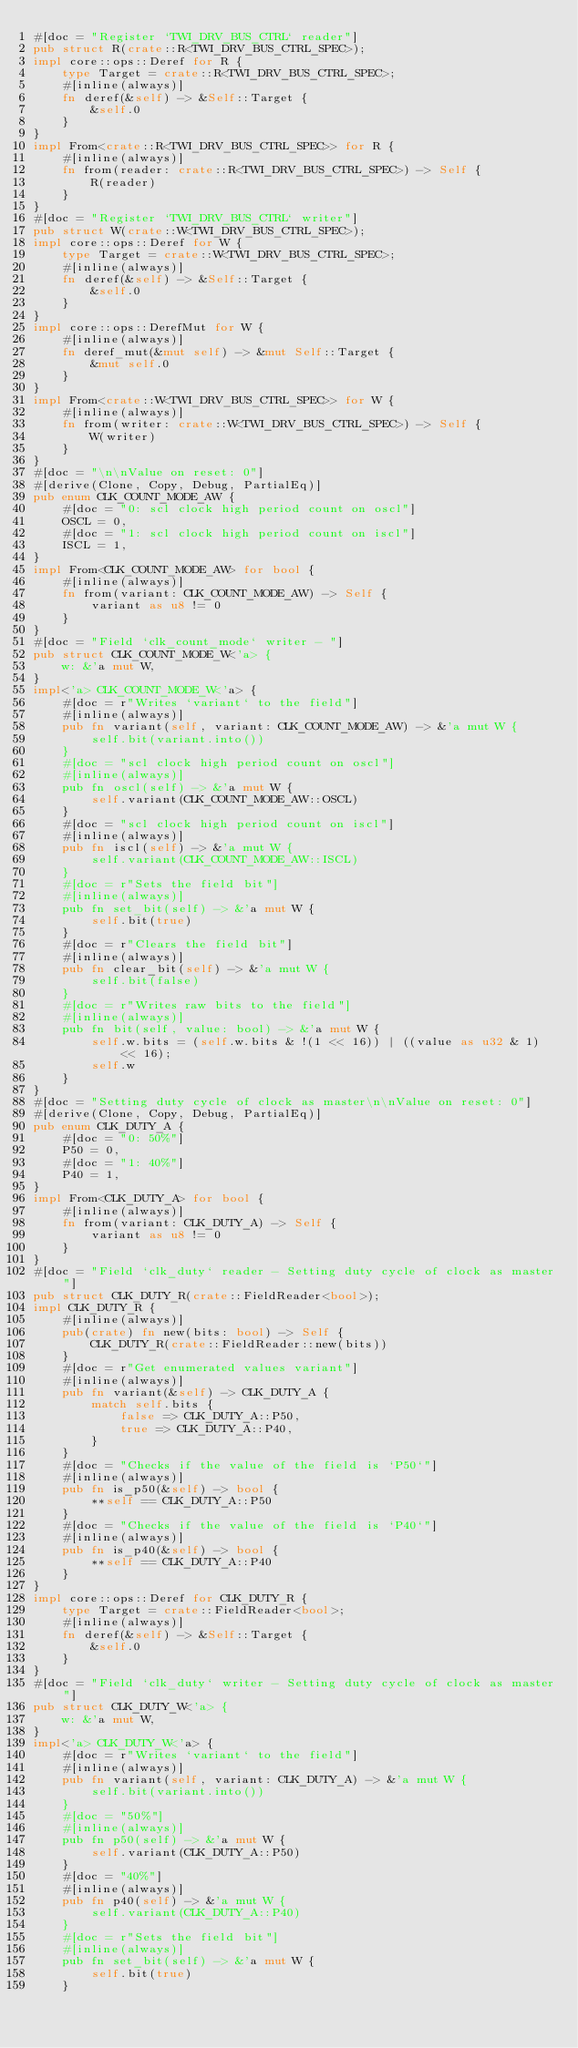Convert code to text. <code><loc_0><loc_0><loc_500><loc_500><_Rust_>#[doc = "Register `TWI_DRV_BUS_CTRL` reader"]
pub struct R(crate::R<TWI_DRV_BUS_CTRL_SPEC>);
impl core::ops::Deref for R {
    type Target = crate::R<TWI_DRV_BUS_CTRL_SPEC>;
    #[inline(always)]
    fn deref(&self) -> &Self::Target {
        &self.0
    }
}
impl From<crate::R<TWI_DRV_BUS_CTRL_SPEC>> for R {
    #[inline(always)]
    fn from(reader: crate::R<TWI_DRV_BUS_CTRL_SPEC>) -> Self {
        R(reader)
    }
}
#[doc = "Register `TWI_DRV_BUS_CTRL` writer"]
pub struct W(crate::W<TWI_DRV_BUS_CTRL_SPEC>);
impl core::ops::Deref for W {
    type Target = crate::W<TWI_DRV_BUS_CTRL_SPEC>;
    #[inline(always)]
    fn deref(&self) -> &Self::Target {
        &self.0
    }
}
impl core::ops::DerefMut for W {
    #[inline(always)]
    fn deref_mut(&mut self) -> &mut Self::Target {
        &mut self.0
    }
}
impl From<crate::W<TWI_DRV_BUS_CTRL_SPEC>> for W {
    #[inline(always)]
    fn from(writer: crate::W<TWI_DRV_BUS_CTRL_SPEC>) -> Self {
        W(writer)
    }
}
#[doc = "\n\nValue on reset: 0"]
#[derive(Clone, Copy, Debug, PartialEq)]
pub enum CLK_COUNT_MODE_AW {
    #[doc = "0: scl clock high period count on oscl"]
    OSCL = 0,
    #[doc = "1: scl clock high period count on iscl"]
    ISCL = 1,
}
impl From<CLK_COUNT_MODE_AW> for bool {
    #[inline(always)]
    fn from(variant: CLK_COUNT_MODE_AW) -> Self {
        variant as u8 != 0
    }
}
#[doc = "Field `clk_count_mode` writer - "]
pub struct CLK_COUNT_MODE_W<'a> {
    w: &'a mut W,
}
impl<'a> CLK_COUNT_MODE_W<'a> {
    #[doc = r"Writes `variant` to the field"]
    #[inline(always)]
    pub fn variant(self, variant: CLK_COUNT_MODE_AW) -> &'a mut W {
        self.bit(variant.into())
    }
    #[doc = "scl clock high period count on oscl"]
    #[inline(always)]
    pub fn oscl(self) -> &'a mut W {
        self.variant(CLK_COUNT_MODE_AW::OSCL)
    }
    #[doc = "scl clock high period count on iscl"]
    #[inline(always)]
    pub fn iscl(self) -> &'a mut W {
        self.variant(CLK_COUNT_MODE_AW::ISCL)
    }
    #[doc = r"Sets the field bit"]
    #[inline(always)]
    pub fn set_bit(self) -> &'a mut W {
        self.bit(true)
    }
    #[doc = r"Clears the field bit"]
    #[inline(always)]
    pub fn clear_bit(self) -> &'a mut W {
        self.bit(false)
    }
    #[doc = r"Writes raw bits to the field"]
    #[inline(always)]
    pub fn bit(self, value: bool) -> &'a mut W {
        self.w.bits = (self.w.bits & !(1 << 16)) | ((value as u32 & 1) << 16);
        self.w
    }
}
#[doc = "Setting duty cycle of clock as master\n\nValue on reset: 0"]
#[derive(Clone, Copy, Debug, PartialEq)]
pub enum CLK_DUTY_A {
    #[doc = "0: 50%"]
    P50 = 0,
    #[doc = "1: 40%"]
    P40 = 1,
}
impl From<CLK_DUTY_A> for bool {
    #[inline(always)]
    fn from(variant: CLK_DUTY_A) -> Self {
        variant as u8 != 0
    }
}
#[doc = "Field `clk_duty` reader - Setting duty cycle of clock as master"]
pub struct CLK_DUTY_R(crate::FieldReader<bool>);
impl CLK_DUTY_R {
    #[inline(always)]
    pub(crate) fn new(bits: bool) -> Self {
        CLK_DUTY_R(crate::FieldReader::new(bits))
    }
    #[doc = r"Get enumerated values variant"]
    #[inline(always)]
    pub fn variant(&self) -> CLK_DUTY_A {
        match self.bits {
            false => CLK_DUTY_A::P50,
            true => CLK_DUTY_A::P40,
        }
    }
    #[doc = "Checks if the value of the field is `P50`"]
    #[inline(always)]
    pub fn is_p50(&self) -> bool {
        **self == CLK_DUTY_A::P50
    }
    #[doc = "Checks if the value of the field is `P40`"]
    #[inline(always)]
    pub fn is_p40(&self) -> bool {
        **self == CLK_DUTY_A::P40
    }
}
impl core::ops::Deref for CLK_DUTY_R {
    type Target = crate::FieldReader<bool>;
    #[inline(always)]
    fn deref(&self) -> &Self::Target {
        &self.0
    }
}
#[doc = "Field `clk_duty` writer - Setting duty cycle of clock as master"]
pub struct CLK_DUTY_W<'a> {
    w: &'a mut W,
}
impl<'a> CLK_DUTY_W<'a> {
    #[doc = r"Writes `variant` to the field"]
    #[inline(always)]
    pub fn variant(self, variant: CLK_DUTY_A) -> &'a mut W {
        self.bit(variant.into())
    }
    #[doc = "50%"]
    #[inline(always)]
    pub fn p50(self) -> &'a mut W {
        self.variant(CLK_DUTY_A::P50)
    }
    #[doc = "40%"]
    #[inline(always)]
    pub fn p40(self) -> &'a mut W {
        self.variant(CLK_DUTY_A::P40)
    }
    #[doc = r"Sets the field bit"]
    #[inline(always)]
    pub fn set_bit(self) -> &'a mut W {
        self.bit(true)
    }</code> 